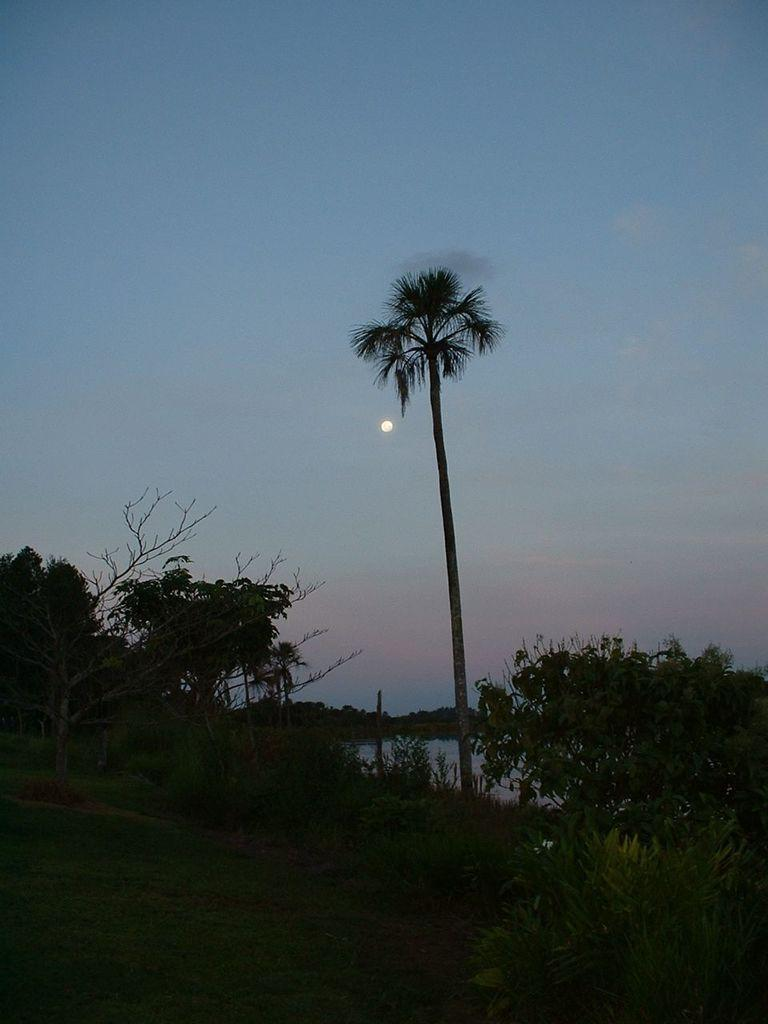What type of vegetation is present on the ground in the center of the image? There is grass on the ground in the center of the image. What other types of vegetation can be seen in the image? There are plants visible in the image. What can be seen in the background of the image? There are trees in the background of the image. How would you describe the sky in the image? The sky is cloudy in the image. What celestial body is visible in the sky? The moon is visible in the sky. How many fangs can be seen on the tree in the image? There is no tree with fangs present in the image; trees do not have fangs. What type of apple is being eaten by the creature in the image? There is no creature or apple present in the image. 